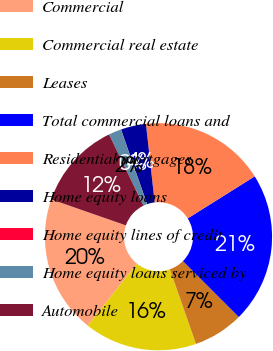<chart> <loc_0><loc_0><loc_500><loc_500><pie_chart><fcel>Commercial<fcel>Commercial real estate<fcel>Leases<fcel>Total commercial loans and<fcel>Residential mortgages<fcel>Home equity loans<fcel>Home equity lines of credit<fcel>Home equity loans serviced by<fcel>Automobile<nl><fcel>19.63%<fcel>16.06%<fcel>7.15%<fcel>21.41%<fcel>17.85%<fcel>3.58%<fcel>0.02%<fcel>1.8%<fcel>12.5%<nl></chart> 